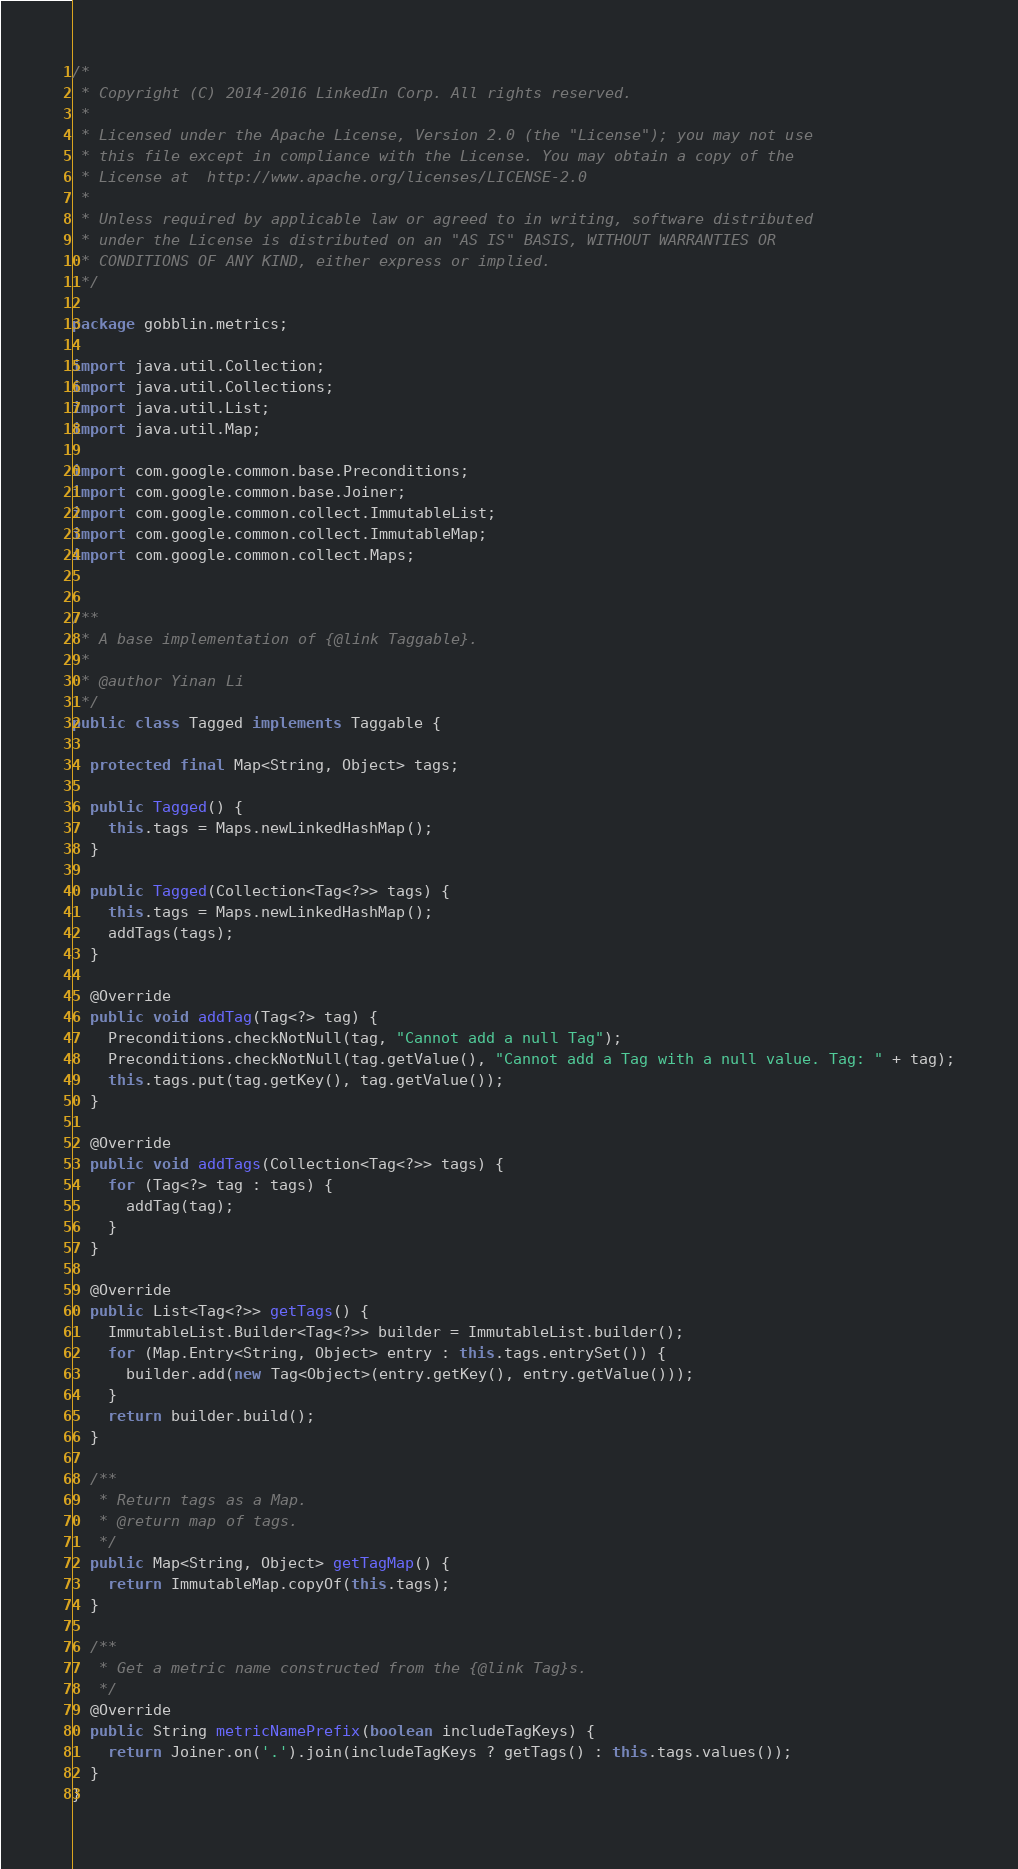<code> <loc_0><loc_0><loc_500><loc_500><_Java_>/*
 * Copyright (C) 2014-2016 LinkedIn Corp. All rights reserved.
 *
 * Licensed under the Apache License, Version 2.0 (the "License"); you may not use
 * this file except in compliance with the License. You may obtain a copy of the
 * License at  http://www.apache.org/licenses/LICENSE-2.0
 *
 * Unless required by applicable law or agreed to in writing, software distributed
 * under the License is distributed on an "AS IS" BASIS, WITHOUT WARRANTIES OR
 * CONDITIONS OF ANY KIND, either express or implied.
 */

package gobblin.metrics;

import java.util.Collection;
import java.util.Collections;
import java.util.List;
import java.util.Map;

import com.google.common.base.Preconditions;
import com.google.common.base.Joiner;
import com.google.common.collect.ImmutableList;
import com.google.common.collect.ImmutableMap;
import com.google.common.collect.Maps;


/**
 * A base implementation of {@link Taggable}.
 *
 * @author Yinan Li
 */
public class Tagged implements Taggable {

  protected final Map<String, Object> tags;

  public Tagged() {
    this.tags = Maps.newLinkedHashMap();
  }

  public Tagged(Collection<Tag<?>> tags) {
    this.tags = Maps.newLinkedHashMap();
    addTags(tags);
  }

  @Override
  public void addTag(Tag<?> tag) {
    Preconditions.checkNotNull(tag, "Cannot add a null Tag");
    Preconditions.checkNotNull(tag.getValue(), "Cannot add a Tag with a null value. Tag: " + tag);
    this.tags.put(tag.getKey(), tag.getValue());
  }

  @Override
  public void addTags(Collection<Tag<?>> tags) {
    for (Tag<?> tag : tags) {
      addTag(tag);
    }
  }

  @Override
  public List<Tag<?>> getTags() {
    ImmutableList.Builder<Tag<?>> builder = ImmutableList.builder();
    for (Map.Entry<String, Object> entry : this.tags.entrySet()) {
      builder.add(new Tag<Object>(entry.getKey(), entry.getValue()));
    }
    return builder.build();
  }

  /**
   * Return tags as a Map.
   * @return map of tags.
   */
  public Map<String, Object> getTagMap() {
    return ImmutableMap.copyOf(this.tags);
  }

  /**
   * Get a metric name constructed from the {@link Tag}s.
   */
  @Override
  public String metricNamePrefix(boolean includeTagKeys) {
    return Joiner.on('.').join(includeTagKeys ? getTags() : this.tags.values());
  }
}
</code> 